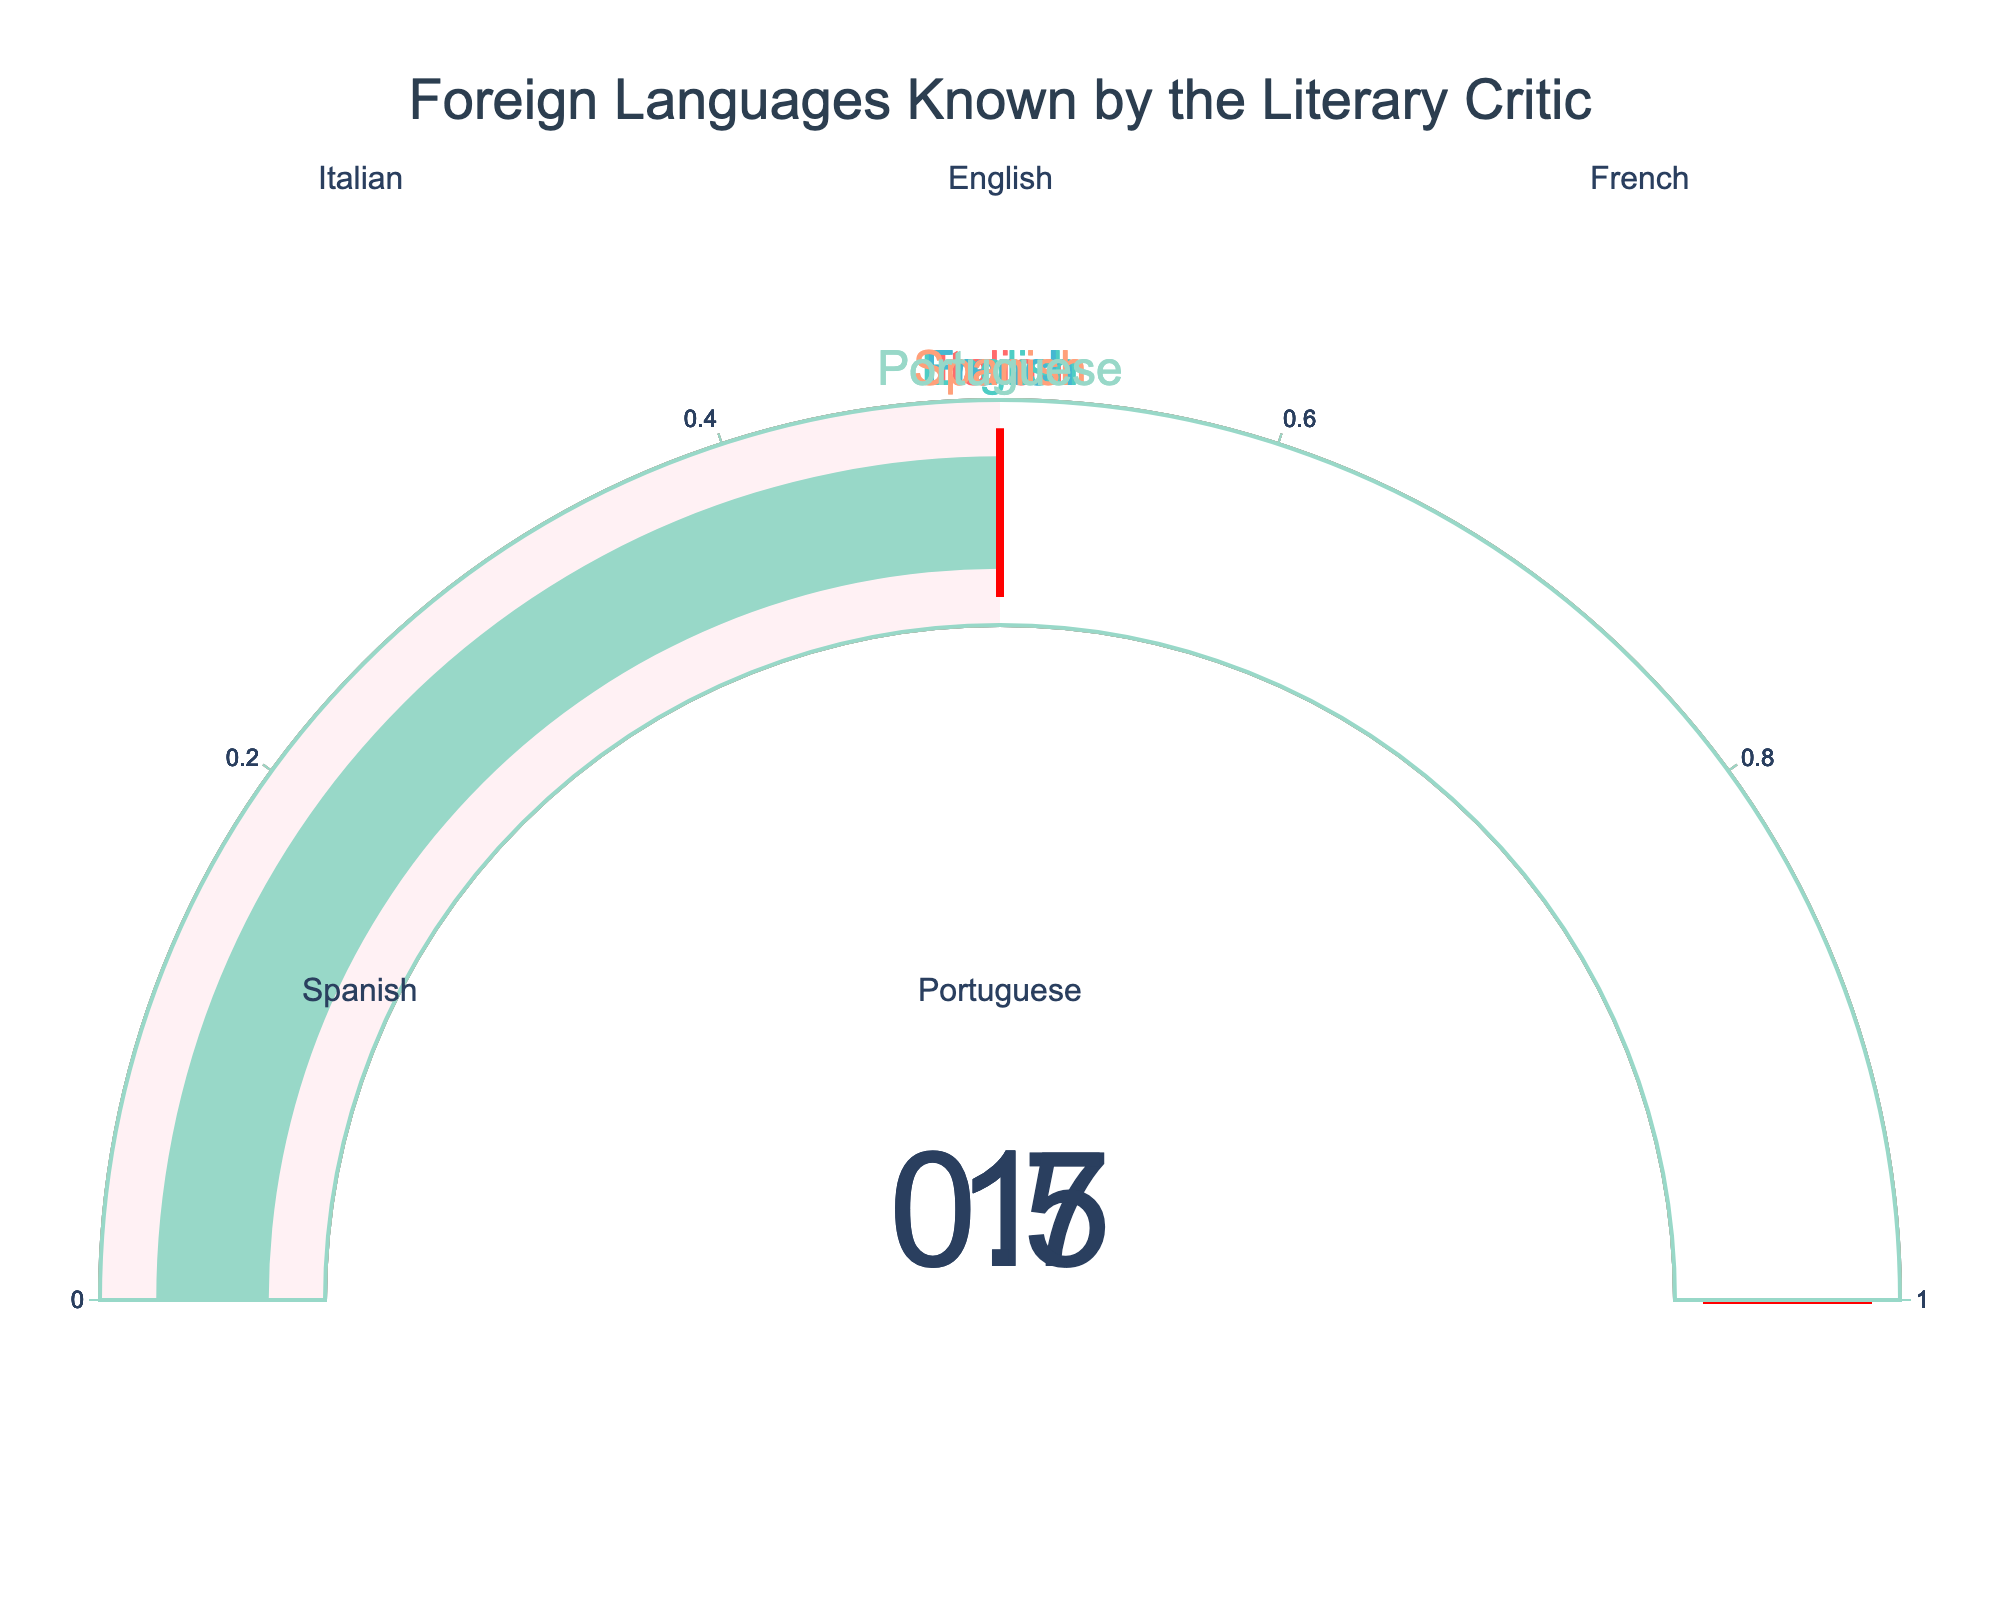What's the title of the chart? The title is displayed prominently at the top of the chart. It indicates what the chart is about.
Answer: "Foreign Languages Known by the Literary Critic" How many foreign languages does the critic know at least partially? Each gauge represents a foreign language with a value greater than 0. This includes Italian, English, French, Spanish, and Portuguese.
Answer: 5 languages Which language does the critic know least proficiently? Among all the gauges, Portuguese has the lowest value at 0.5.
Answer: Portuguese What is the average proficiency level across all foreign languages for the critic? To find the average, sum the values for Italian (1), English (1), French (1), Spanish (0.7), and Portuguese (0.5), and then divide by the number of languages, which is 5. The sum is 1 + 1 + 1 + 0.7 + 0.5 = 4.2. The average is 4.2 / 5 = 0.84.
Answer: 0.84 Which language has a proficiency level of 0.7? The gauge for Spanish shows a value of 0.7, indicating the proficiency level for that language.
Answer: Spanish How does the proficiency in English compare to that in French? Both English and French have a gauge value of 1, indicating the critic knows both languages equally well.
Answer: They are equal What is the total summed value of the proficiency levels for English and French? Each of these languages has a gauge value of 1. Sum them together: 1 + 1 = 2.
Answer: 2 Are there any languages that the critic is perfectly fluent in? A value of 1 indicates perfect fluency, which is the case for Italian, English, and French.
Answer: Yes By how much does the critic's knowledge of Spanish fall short of 1? The value for Spanish is 0.7. Subtracting this from 1 gives the shortfall: 1 - 0.7 = 0.3.
Answer: 0.3 Among Italian, English, and French, which language does the critic know best? All three have the same value of 1, indicating equal proficiency.
Answer: All are equal 